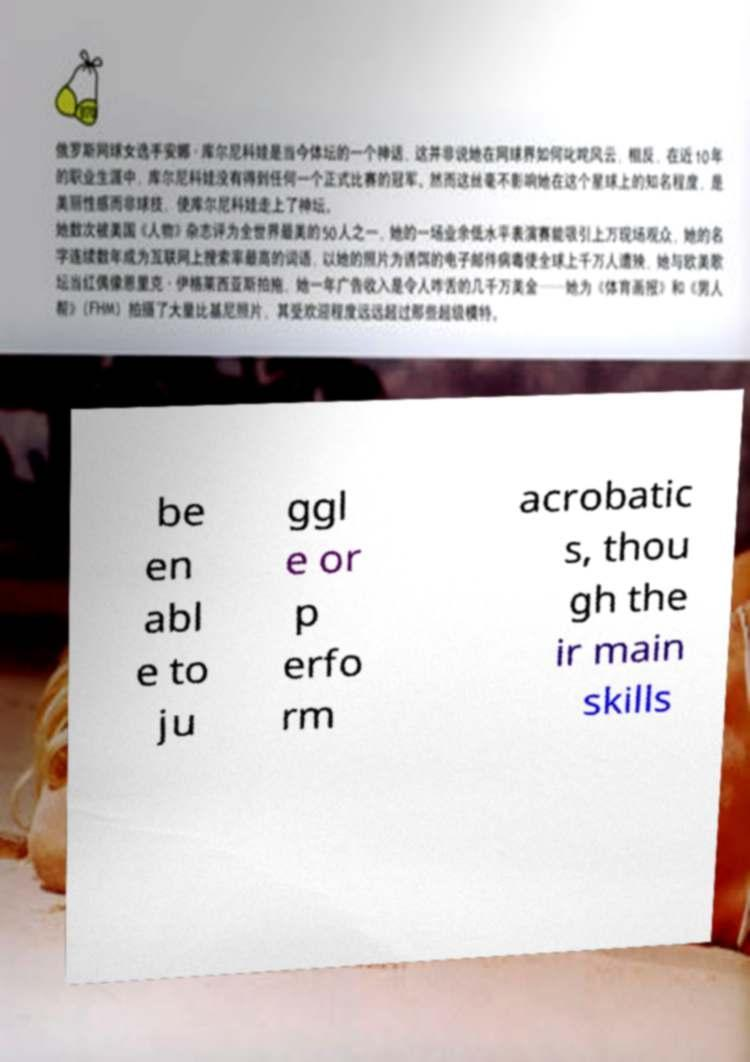Could you extract and type out the text from this image? be en abl e to ju ggl e or p erfo rm acrobatic s, thou gh the ir main skills 